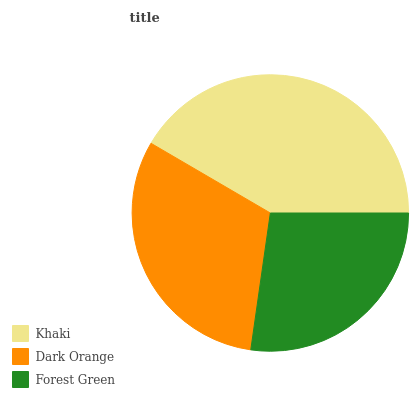Is Forest Green the minimum?
Answer yes or no. Yes. Is Khaki the maximum?
Answer yes or no. Yes. Is Dark Orange the minimum?
Answer yes or no. No. Is Dark Orange the maximum?
Answer yes or no. No. Is Khaki greater than Dark Orange?
Answer yes or no. Yes. Is Dark Orange less than Khaki?
Answer yes or no. Yes. Is Dark Orange greater than Khaki?
Answer yes or no. No. Is Khaki less than Dark Orange?
Answer yes or no. No. Is Dark Orange the high median?
Answer yes or no. Yes. Is Dark Orange the low median?
Answer yes or no. Yes. Is Khaki the high median?
Answer yes or no. No. Is Forest Green the low median?
Answer yes or no. No. 